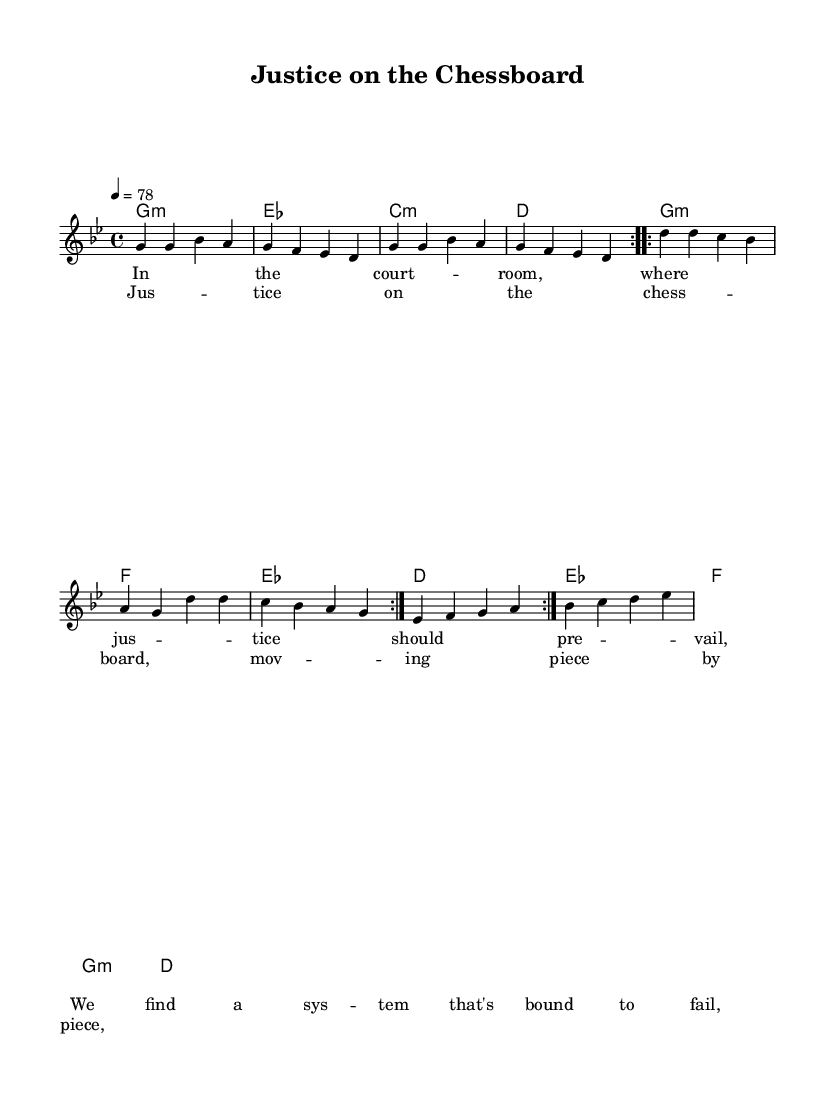What is the key signature of this music? The key signature is G minor, which has two flats. The flats are indicated at the beginning of the staff.
Answer: G minor What is the time signature of this music? The time signature is 4/4, which means there are four beats in each measure. This is shown at the beginning of the staff, next to the key signature.
Answer: 4/4 What is the tempo marking for this piece? The tempo marking indicates that the piece should be played at 78 beats per minute, as shown above the staff.
Answer: 78 How many times is the melody repeated in the first section? The melody is repeated twice, as indicated by the "volta" markings. Each volta signifies a section that is repeated.
Answer: 2 What is the first chord of the piece? The first chord is G minor, indicated at the beginning of the chord names line. This is the chord that sets the harmonic context for the piece.
Answer: G minor What is the theme of the lyrics in this song? The theme addresses justice and systemic failures, as indicated by the lines in the verse that mention the courtroom and justice. The lyrics suggest a critique of the legal system.
Answer: Justice and systemic failures What is the purpose of the chorus in this reggae piece? The purpose of the chorus is to emphasize the central idea of justice being a process, much like a game of chess, where movements are deliberate and strategic. This reflects the song's protest message.
Answer: Emphasize justice as a process 